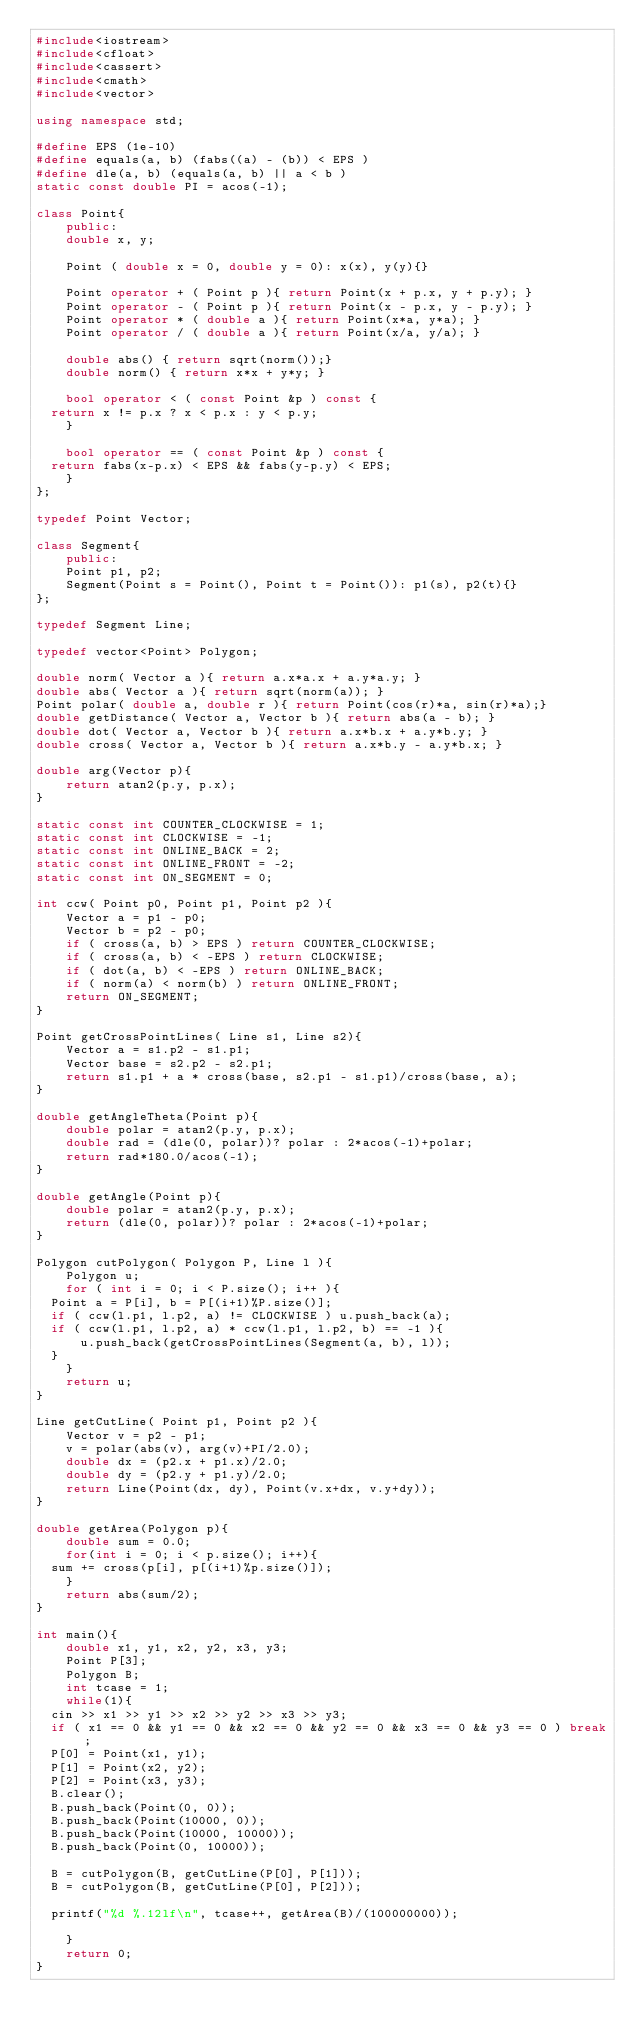<code> <loc_0><loc_0><loc_500><loc_500><_C++_>#include<iostream>
#include<cfloat>
#include<cassert>
#include<cmath>
#include<vector>

using namespace std;

#define EPS (1e-10)
#define equals(a, b) (fabs((a) - (b)) < EPS )
#define dle(a, b) (equals(a, b) || a < b )
static const double PI = acos(-1);

class Point{
    public:
    double x, y;
    
    Point ( double x = 0, double y = 0): x(x), y(y){}
    
    Point operator + ( Point p ){ return Point(x + p.x, y + p.y); }
    Point operator - ( Point p ){ return Point(x - p.x, y - p.y); }
    Point operator * ( double a ){ return Point(x*a, y*a); }
    Point operator / ( double a ){ return Point(x/a, y/a); }

    double abs() { return sqrt(norm());}
    double norm() { return x*x + y*y; }

    bool operator < ( const Point &p ) const {
	return x != p.x ? x < p.x : y < p.y;
    }

    bool operator == ( const Point &p ) const {
	return fabs(x-p.x) < EPS && fabs(y-p.y) < EPS;
    }
};

typedef Point Vector;

class Segment{
    public:
    Point p1, p2;
    Segment(Point s = Point(), Point t = Point()): p1(s), p2(t){}
};

typedef Segment Line;

typedef vector<Point> Polygon;

double norm( Vector a ){ return a.x*a.x + a.y*a.y; }
double abs( Vector a ){ return sqrt(norm(a)); }
Point polar( double a, double r ){ return Point(cos(r)*a, sin(r)*a);}
double getDistance( Vector a, Vector b ){ return abs(a - b); }
double dot( Vector a, Vector b ){ return a.x*b.x + a.y*b.y; }
double cross( Vector a, Vector b ){ return a.x*b.y - a.y*b.x; }

double arg(Vector p){
    return atan2(p.y, p.x);
}

static const int COUNTER_CLOCKWISE = 1;
static const int CLOCKWISE = -1;
static const int ONLINE_BACK = 2;
static const int ONLINE_FRONT = -2;
static const int ON_SEGMENT = 0;

int ccw( Point p0, Point p1, Point p2 ){
    Vector a = p1 - p0;
    Vector b = p2 - p0;
    if ( cross(a, b) > EPS ) return COUNTER_CLOCKWISE;
    if ( cross(a, b) < -EPS ) return CLOCKWISE;
    if ( dot(a, b) < -EPS ) return ONLINE_BACK;
    if ( norm(a) < norm(b) ) return ONLINE_FRONT;
    return ON_SEGMENT;
}

Point getCrossPointLines( Line s1, Line s2){
    Vector a = s1.p2 - s1.p1;
    Vector base = s2.p2 - s2.p1;
    return s1.p1 + a * cross(base, s2.p1 - s1.p1)/cross(base, a);
}

double getAngleTheta(Point p){
    double polar = atan2(p.y, p.x);
    double rad = (dle(0, polar))? polar : 2*acos(-1)+polar;
    return rad*180.0/acos(-1);
}

double getAngle(Point p){
    double polar = atan2(p.y, p.x);
    return (dle(0, polar))? polar : 2*acos(-1)+polar;
}

Polygon cutPolygon( Polygon P, Line l ){
    Polygon u;
    for ( int i = 0; i < P.size(); i++ ){
	Point a = P[i], b = P[(i+1)%P.size()];
	if ( ccw(l.p1, l.p2, a) != CLOCKWISE ) u.push_back(a);
	if ( ccw(l.p1, l.p2, a) * ccw(l.p1, l.p2, b) == -1 ){
	    u.push_back(getCrossPointLines(Segment(a, b), l));
	}
    }
    return u;
}

Line getCutLine( Point p1, Point p2 ){
    Vector v = p2 - p1;
    v = polar(abs(v), arg(v)+PI/2.0);
    double dx = (p2.x + p1.x)/2.0;
    double dy = (p2.y + p1.y)/2.0;
    return Line(Point(dx, dy), Point(v.x+dx, v.y+dy));
}

double getArea(Polygon p){
    double sum = 0.0;
    for(int i = 0; i < p.size(); i++){
	sum += cross(p[i], p[(i+1)%p.size()]);
    }
    return abs(sum/2);
}

int main(){
    double x1, y1, x2, y2, x3, y3;
    Point P[3];
    Polygon B; 
    int tcase = 1;
    while(1){
	cin >> x1 >> y1 >> x2 >> y2 >> x3 >> y3;
	if ( x1 == 0 && y1 == 0 && x2 == 0 && y2 == 0 && x3 == 0 && y3 == 0 ) break;
	P[0] = Point(x1, y1);
	P[1] = Point(x2, y2);
	P[2] = Point(x3, y3);
	B.clear();
	B.push_back(Point(0, 0));
	B.push_back(Point(10000, 0));
	B.push_back(Point(10000, 10000));
	B.push_back(Point(0, 10000));

	B = cutPolygon(B, getCutLine(P[0], P[1]));
	B = cutPolygon(B, getCutLine(P[0], P[2]));
	
	printf("%d %.12lf\n", tcase++, getArea(B)/(100000000));

    }
    return 0;
}</code> 